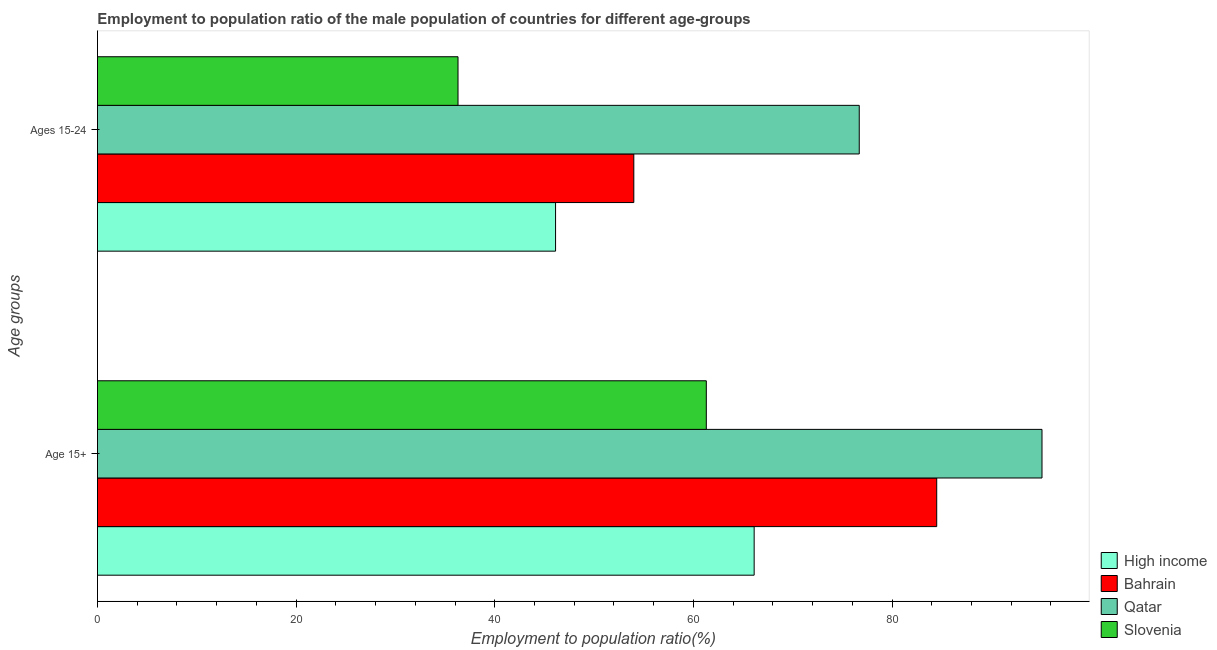How many groups of bars are there?
Your response must be concise. 2. Are the number of bars on each tick of the Y-axis equal?
Offer a very short reply. Yes. How many bars are there on the 1st tick from the top?
Give a very brief answer. 4. How many bars are there on the 2nd tick from the bottom?
Your answer should be very brief. 4. What is the label of the 2nd group of bars from the top?
Your answer should be very brief. Age 15+. What is the employment to population ratio(age 15+) in Slovenia?
Offer a very short reply. 61.3. Across all countries, what is the maximum employment to population ratio(age 15-24)?
Your response must be concise. 76.7. Across all countries, what is the minimum employment to population ratio(age 15-24)?
Keep it short and to the point. 36.3. In which country was the employment to population ratio(age 15+) maximum?
Provide a short and direct response. Qatar. In which country was the employment to population ratio(age 15+) minimum?
Offer a terse response. Slovenia. What is the total employment to population ratio(age 15+) in the graph?
Provide a succinct answer. 307.02. What is the difference between the employment to population ratio(age 15+) in Qatar and that in High income?
Your answer should be compact. 28.98. What is the difference between the employment to population ratio(age 15-24) in Qatar and the employment to population ratio(age 15+) in Bahrain?
Your answer should be very brief. -7.8. What is the average employment to population ratio(age 15+) per country?
Your answer should be compact. 76.75. What is the difference between the employment to population ratio(age 15+) and employment to population ratio(age 15-24) in Bahrain?
Keep it short and to the point. 30.5. What is the ratio of the employment to population ratio(age 15+) in Bahrain to that in Slovenia?
Keep it short and to the point. 1.38. In how many countries, is the employment to population ratio(age 15-24) greater than the average employment to population ratio(age 15-24) taken over all countries?
Your response must be concise. 2. What does the 3rd bar from the top in Ages 15-24 represents?
Provide a succinct answer. Bahrain. What does the 3rd bar from the bottom in Age 15+ represents?
Keep it short and to the point. Qatar. How many bars are there?
Provide a succinct answer. 8. How many countries are there in the graph?
Provide a short and direct response. 4. Does the graph contain any zero values?
Offer a terse response. No. Does the graph contain grids?
Make the answer very short. No. How are the legend labels stacked?
Ensure brevity in your answer.  Vertical. What is the title of the graph?
Your response must be concise. Employment to population ratio of the male population of countries for different age-groups. What is the label or title of the X-axis?
Give a very brief answer. Employment to population ratio(%). What is the label or title of the Y-axis?
Your answer should be compact. Age groups. What is the Employment to population ratio(%) in High income in Age 15+?
Offer a very short reply. 66.12. What is the Employment to population ratio(%) of Bahrain in Age 15+?
Offer a very short reply. 84.5. What is the Employment to population ratio(%) of Qatar in Age 15+?
Give a very brief answer. 95.1. What is the Employment to population ratio(%) of Slovenia in Age 15+?
Keep it short and to the point. 61.3. What is the Employment to population ratio(%) in High income in Ages 15-24?
Make the answer very short. 46.12. What is the Employment to population ratio(%) in Qatar in Ages 15-24?
Provide a succinct answer. 76.7. What is the Employment to population ratio(%) of Slovenia in Ages 15-24?
Your answer should be compact. 36.3. Across all Age groups, what is the maximum Employment to population ratio(%) in High income?
Your response must be concise. 66.12. Across all Age groups, what is the maximum Employment to population ratio(%) in Bahrain?
Provide a short and direct response. 84.5. Across all Age groups, what is the maximum Employment to population ratio(%) of Qatar?
Offer a very short reply. 95.1. Across all Age groups, what is the maximum Employment to population ratio(%) of Slovenia?
Offer a very short reply. 61.3. Across all Age groups, what is the minimum Employment to population ratio(%) of High income?
Give a very brief answer. 46.12. Across all Age groups, what is the minimum Employment to population ratio(%) of Qatar?
Your response must be concise. 76.7. Across all Age groups, what is the minimum Employment to population ratio(%) of Slovenia?
Offer a terse response. 36.3. What is the total Employment to population ratio(%) of High income in the graph?
Offer a terse response. 112.24. What is the total Employment to population ratio(%) of Bahrain in the graph?
Offer a very short reply. 138.5. What is the total Employment to population ratio(%) in Qatar in the graph?
Offer a terse response. 171.8. What is the total Employment to population ratio(%) of Slovenia in the graph?
Your answer should be compact. 97.6. What is the difference between the Employment to population ratio(%) in High income in Age 15+ and that in Ages 15-24?
Ensure brevity in your answer.  20. What is the difference between the Employment to population ratio(%) in Bahrain in Age 15+ and that in Ages 15-24?
Give a very brief answer. 30.5. What is the difference between the Employment to population ratio(%) of Qatar in Age 15+ and that in Ages 15-24?
Make the answer very short. 18.4. What is the difference between the Employment to population ratio(%) of High income in Age 15+ and the Employment to population ratio(%) of Bahrain in Ages 15-24?
Provide a succinct answer. 12.12. What is the difference between the Employment to population ratio(%) of High income in Age 15+ and the Employment to population ratio(%) of Qatar in Ages 15-24?
Offer a terse response. -10.58. What is the difference between the Employment to population ratio(%) of High income in Age 15+ and the Employment to population ratio(%) of Slovenia in Ages 15-24?
Your answer should be very brief. 29.82. What is the difference between the Employment to population ratio(%) in Bahrain in Age 15+ and the Employment to population ratio(%) in Qatar in Ages 15-24?
Provide a succinct answer. 7.8. What is the difference between the Employment to population ratio(%) of Bahrain in Age 15+ and the Employment to population ratio(%) of Slovenia in Ages 15-24?
Provide a short and direct response. 48.2. What is the difference between the Employment to population ratio(%) in Qatar in Age 15+ and the Employment to population ratio(%) in Slovenia in Ages 15-24?
Keep it short and to the point. 58.8. What is the average Employment to population ratio(%) in High income per Age groups?
Your answer should be very brief. 56.12. What is the average Employment to population ratio(%) of Bahrain per Age groups?
Ensure brevity in your answer.  69.25. What is the average Employment to population ratio(%) in Qatar per Age groups?
Your answer should be compact. 85.9. What is the average Employment to population ratio(%) of Slovenia per Age groups?
Keep it short and to the point. 48.8. What is the difference between the Employment to population ratio(%) in High income and Employment to population ratio(%) in Bahrain in Age 15+?
Keep it short and to the point. -18.38. What is the difference between the Employment to population ratio(%) in High income and Employment to population ratio(%) in Qatar in Age 15+?
Your answer should be very brief. -28.98. What is the difference between the Employment to population ratio(%) of High income and Employment to population ratio(%) of Slovenia in Age 15+?
Offer a terse response. 4.82. What is the difference between the Employment to population ratio(%) in Bahrain and Employment to population ratio(%) in Slovenia in Age 15+?
Keep it short and to the point. 23.2. What is the difference between the Employment to population ratio(%) of Qatar and Employment to population ratio(%) of Slovenia in Age 15+?
Keep it short and to the point. 33.8. What is the difference between the Employment to population ratio(%) in High income and Employment to population ratio(%) in Bahrain in Ages 15-24?
Your answer should be compact. -7.88. What is the difference between the Employment to population ratio(%) of High income and Employment to population ratio(%) of Qatar in Ages 15-24?
Provide a succinct answer. -30.58. What is the difference between the Employment to population ratio(%) of High income and Employment to population ratio(%) of Slovenia in Ages 15-24?
Ensure brevity in your answer.  9.82. What is the difference between the Employment to population ratio(%) in Bahrain and Employment to population ratio(%) in Qatar in Ages 15-24?
Ensure brevity in your answer.  -22.7. What is the difference between the Employment to population ratio(%) of Bahrain and Employment to population ratio(%) of Slovenia in Ages 15-24?
Ensure brevity in your answer.  17.7. What is the difference between the Employment to population ratio(%) of Qatar and Employment to population ratio(%) of Slovenia in Ages 15-24?
Provide a short and direct response. 40.4. What is the ratio of the Employment to population ratio(%) in High income in Age 15+ to that in Ages 15-24?
Provide a short and direct response. 1.43. What is the ratio of the Employment to population ratio(%) in Bahrain in Age 15+ to that in Ages 15-24?
Your response must be concise. 1.56. What is the ratio of the Employment to population ratio(%) in Qatar in Age 15+ to that in Ages 15-24?
Offer a terse response. 1.24. What is the ratio of the Employment to population ratio(%) of Slovenia in Age 15+ to that in Ages 15-24?
Your answer should be very brief. 1.69. What is the difference between the highest and the second highest Employment to population ratio(%) in High income?
Keep it short and to the point. 20. What is the difference between the highest and the second highest Employment to population ratio(%) in Bahrain?
Keep it short and to the point. 30.5. What is the difference between the highest and the lowest Employment to population ratio(%) of High income?
Keep it short and to the point. 20. What is the difference between the highest and the lowest Employment to population ratio(%) of Bahrain?
Your answer should be compact. 30.5. What is the difference between the highest and the lowest Employment to population ratio(%) of Qatar?
Ensure brevity in your answer.  18.4. 